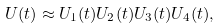<formula> <loc_0><loc_0><loc_500><loc_500>U ( t ) \approx U _ { 1 } ( t ) U _ { 2 } ( t ) U _ { 3 } ( t ) U _ { 4 } ( t ) ,</formula> 